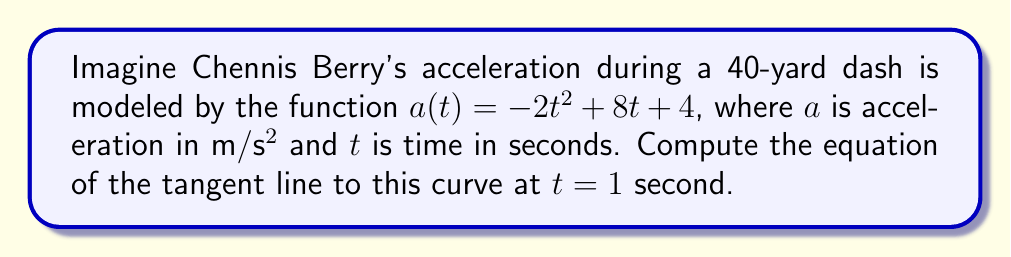Can you answer this question? To find the tangent line, we need to follow these steps:

1) First, we need to find the point on the curve at $t = 1$. Let's call this point $(t_0, a_0)$.
   $t_0 = 1$
   $a_0 = a(1) = -2(1)^2 + 8(1) + 4 = -2 + 8 + 4 = 10$
   So, the point is $(1, 10)$.

2) Next, we need to find the slope of the tangent line. This is given by the derivative of $a(t)$ at $t = 1$.
   $a'(t) = -4t + 8$
   $a'(1) = -4(1) + 8 = 4$

3) Now we have a point $(1, 10)$ and a slope of 4. We can use the point-slope form of a line:
   $y - y_0 = m(x - x_0)$
   Where $(x_0, y_0)$ is our point and $m$ is our slope.

4) Substituting our values:
   $y - 10 = 4(t - 1)$

5) Simplify:
   $y = 4t - 4 + 10$
   $y = 4t + 6$

This is the equation of the tangent line.
Answer: $y = 4t + 6$ 